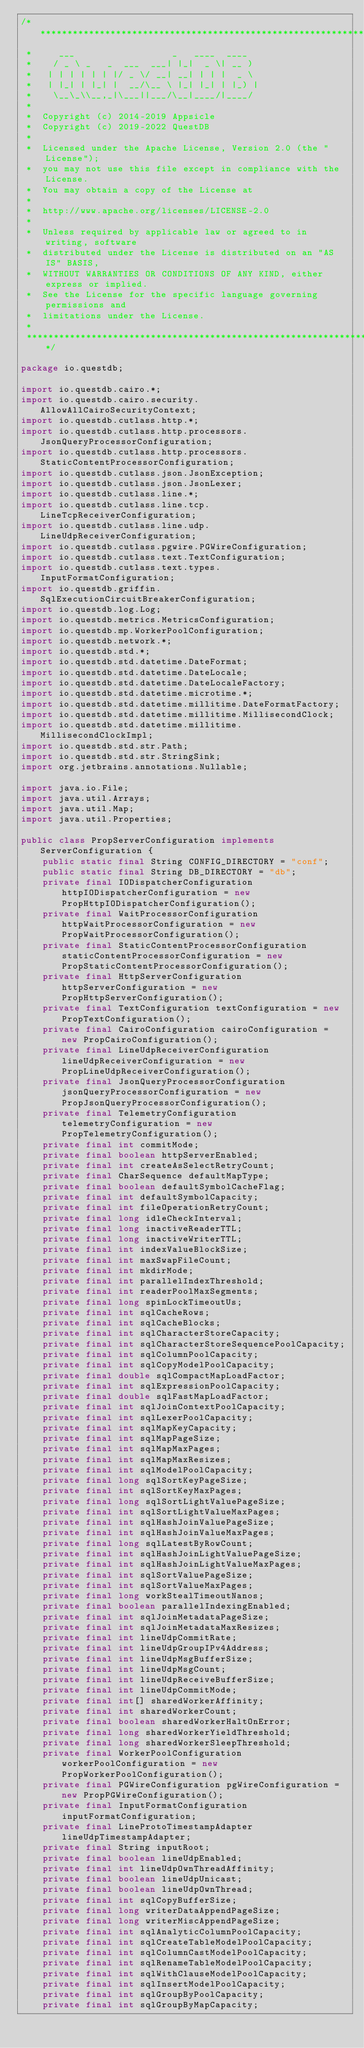Convert code to text. <code><loc_0><loc_0><loc_500><loc_500><_Java_>/*******************************************************************************
 *     ___                  _   ____  ____
 *    / _ \ _   _  ___  ___| |_|  _ \| __ )
 *   | | | | | | |/ _ \/ __| __| | | |  _ \
 *   | |_| | |_| |  __/\__ \ |_| |_| | |_) |
 *    \__\_\\__,_|\___||___/\__|____/|____/
 *
 *  Copyright (c) 2014-2019 Appsicle
 *  Copyright (c) 2019-2022 QuestDB
 *
 *  Licensed under the Apache License, Version 2.0 (the "License");
 *  you may not use this file except in compliance with the License.
 *  You may obtain a copy of the License at
 *
 *  http://www.apache.org/licenses/LICENSE-2.0
 *
 *  Unless required by applicable law or agreed to in writing, software
 *  distributed under the License is distributed on an "AS IS" BASIS,
 *  WITHOUT WARRANTIES OR CONDITIONS OF ANY KIND, either express or implied.
 *  See the License for the specific language governing permissions and
 *  limitations under the License.
 *
 ******************************************************************************/

package io.questdb;

import io.questdb.cairo.*;
import io.questdb.cairo.security.AllowAllCairoSecurityContext;
import io.questdb.cutlass.http.*;
import io.questdb.cutlass.http.processors.JsonQueryProcessorConfiguration;
import io.questdb.cutlass.http.processors.StaticContentProcessorConfiguration;
import io.questdb.cutlass.json.JsonException;
import io.questdb.cutlass.json.JsonLexer;
import io.questdb.cutlass.line.*;
import io.questdb.cutlass.line.tcp.LineTcpReceiverConfiguration;
import io.questdb.cutlass.line.udp.LineUdpReceiverConfiguration;
import io.questdb.cutlass.pgwire.PGWireConfiguration;
import io.questdb.cutlass.text.TextConfiguration;
import io.questdb.cutlass.text.types.InputFormatConfiguration;
import io.questdb.griffin.SqlExecutionCircuitBreakerConfiguration;
import io.questdb.log.Log;
import io.questdb.metrics.MetricsConfiguration;
import io.questdb.mp.WorkerPoolConfiguration;
import io.questdb.network.*;
import io.questdb.std.*;
import io.questdb.std.datetime.DateFormat;
import io.questdb.std.datetime.DateLocale;
import io.questdb.std.datetime.DateLocaleFactory;
import io.questdb.std.datetime.microtime.*;
import io.questdb.std.datetime.millitime.DateFormatFactory;
import io.questdb.std.datetime.millitime.MillisecondClock;
import io.questdb.std.datetime.millitime.MillisecondClockImpl;
import io.questdb.std.str.Path;
import io.questdb.std.str.StringSink;
import org.jetbrains.annotations.Nullable;

import java.io.File;
import java.util.Arrays;
import java.util.Map;
import java.util.Properties;

public class PropServerConfiguration implements ServerConfiguration {
    public static final String CONFIG_DIRECTORY = "conf";
    public static final String DB_DIRECTORY = "db";
    private final IODispatcherConfiguration httpIODispatcherConfiguration = new PropHttpIODispatcherConfiguration();
    private final WaitProcessorConfiguration httpWaitProcessorConfiguration = new PropWaitProcessorConfiguration();
    private final StaticContentProcessorConfiguration staticContentProcessorConfiguration = new PropStaticContentProcessorConfiguration();
    private final HttpServerConfiguration httpServerConfiguration = new PropHttpServerConfiguration();
    private final TextConfiguration textConfiguration = new PropTextConfiguration();
    private final CairoConfiguration cairoConfiguration = new PropCairoConfiguration();
    private final LineUdpReceiverConfiguration lineUdpReceiverConfiguration = new PropLineUdpReceiverConfiguration();
    private final JsonQueryProcessorConfiguration jsonQueryProcessorConfiguration = new PropJsonQueryProcessorConfiguration();
    private final TelemetryConfiguration telemetryConfiguration = new PropTelemetryConfiguration();
    private final int commitMode;
    private final boolean httpServerEnabled;
    private final int createAsSelectRetryCount;
    private final CharSequence defaultMapType;
    private final boolean defaultSymbolCacheFlag;
    private final int defaultSymbolCapacity;
    private final int fileOperationRetryCount;
    private final long idleCheckInterval;
    private final long inactiveReaderTTL;
    private final long inactiveWriterTTL;
    private final int indexValueBlockSize;
    private final int maxSwapFileCount;
    private final int mkdirMode;
    private final int parallelIndexThreshold;
    private final int readerPoolMaxSegments;
    private final long spinLockTimeoutUs;
    private final int sqlCacheRows;
    private final int sqlCacheBlocks;
    private final int sqlCharacterStoreCapacity;
    private final int sqlCharacterStoreSequencePoolCapacity;
    private final int sqlColumnPoolCapacity;
    private final int sqlCopyModelPoolCapacity;
    private final double sqlCompactMapLoadFactor;
    private final int sqlExpressionPoolCapacity;
    private final double sqlFastMapLoadFactor;
    private final int sqlJoinContextPoolCapacity;
    private final int sqlLexerPoolCapacity;
    private final int sqlMapKeyCapacity;
    private final int sqlMapPageSize;
    private final int sqlMapMaxPages;
    private final int sqlMapMaxResizes;
    private final int sqlModelPoolCapacity;
    private final long sqlSortKeyPageSize;
    private final int sqlSortKeyMaxPages;
    private final long sqlSortLightValuePageSize;
    private final int sqlSortLightValueMaxPages;
    private final int sqlHashJoinValuePageSize;
    private final int sqlHashJoinValueMaxPages;
    private final long sqlLatestByRowCount;
    private final int sqlHashJoinLightValuePageSize;
    private final int sqlHashJoinLightValueMaxPages;
    private final int sqlSortValuePageSize;
    private final int sqlSortValueMaxPages;
    private final long workStealTimeoutNanos;
    private final boolean parallelIndexingEnabled;
    private final int sqlJoinMetadataPageSize;
    private final int sqlJoinMetadataMaxResizes;
    private final int lineUdpCommitRate;
    private final int lineUdpGroupIPv4Address;
    private final int lineUdpMsgBufferSize;
    private final int lineUdpMsgCount;
    private final int lineUdpReceiveBufferSize;
    private final int lineUdpCommitMode;
    private final int[] sharedWorkerAffinity;
    private final int sharedWorkerCount;
    private final boolean sharedWorkerHaltOnError;
    private final long sharedWorkerYieldThreshold;
    private final long sharedWorkerSleepThreshold;
    private final WorkerPoolConfiguration workerPoolConfiguration = new PropWorkerPoolConfiguration();
    private final PGWireConfiguration pgWireConfiguration = new PropPGWireConfiguration();
    private final InputFormatConfiguration inputFormatConfiguration;
    private final LineProtoTimestampAdapter lineUdpTimestampAdapter;
    private final String inputRoot;
    private final boolean lineUdpEnabled;
    private final int lineUdpOwnThreadAffinity;
    private final boolean lineUdpUnicast;
    private final boolean lineUdpOwnThread;
    private final int sqlCopyBufferSize;
    private final long writerDataAppendPageSize;
    private final long writerMiscAppendPageSize;
    private final int sqlAnalyticColumnPoolCapacity;
    private final int sqlCreateTableModelPoolCapacity;
    private final int sqlColumnCastModelPoolCapacity;
    private final int sqlRenameTableModelPoolCapacity;
    private final int sqlWithClauseModelPoolCapacity;
    private final int sqlInsertModelPoolCapacity;
    private final int sqlGroupByPoolCapacity;
    private final int sqlGroupByMapCapacity;</code> 